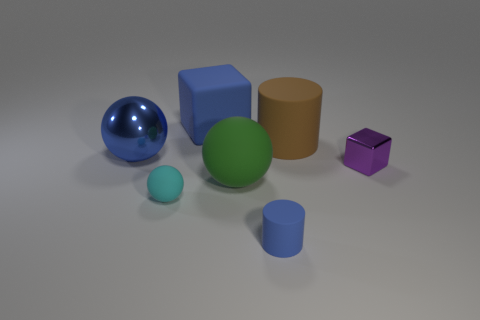There is a sphere that is the same color as the large block; what material is it?
Provide a succinct answer. Metal. There is a big sphere that is behind the tiny purple object; what is its color?
Offer a terse response. Blue. There is a cylinder that is in front of the blue metallic object; does it have the same size as the big block?
Make the answer very short. No. What size is the matte block that is the same color as the small matte cylinder?
Your answer should be compact. Large. Is there a sphere that has the same size as the matte cube?
Provide a succinct answer. Yes. There is a ball behind the small shiny cube; is its color the same as the block that is behind the metal cube?
Make the answer very short. Yes. Are there any large matte cubes of the same color as the big shiny thing?
Provide a short and direct response. Yes. How many other things are the same shape as the cyan object?
Make the answer very short. 2. There is a small rubber thing that is on the right side of the large rubber ball; what is its shape?
Ensure brevity in your answer.  Cylinder. There is a large metallic object; is it the same shape as the large thing that is in front of the blue metal ball?
Ensure brevity in your answer.  Yes. 